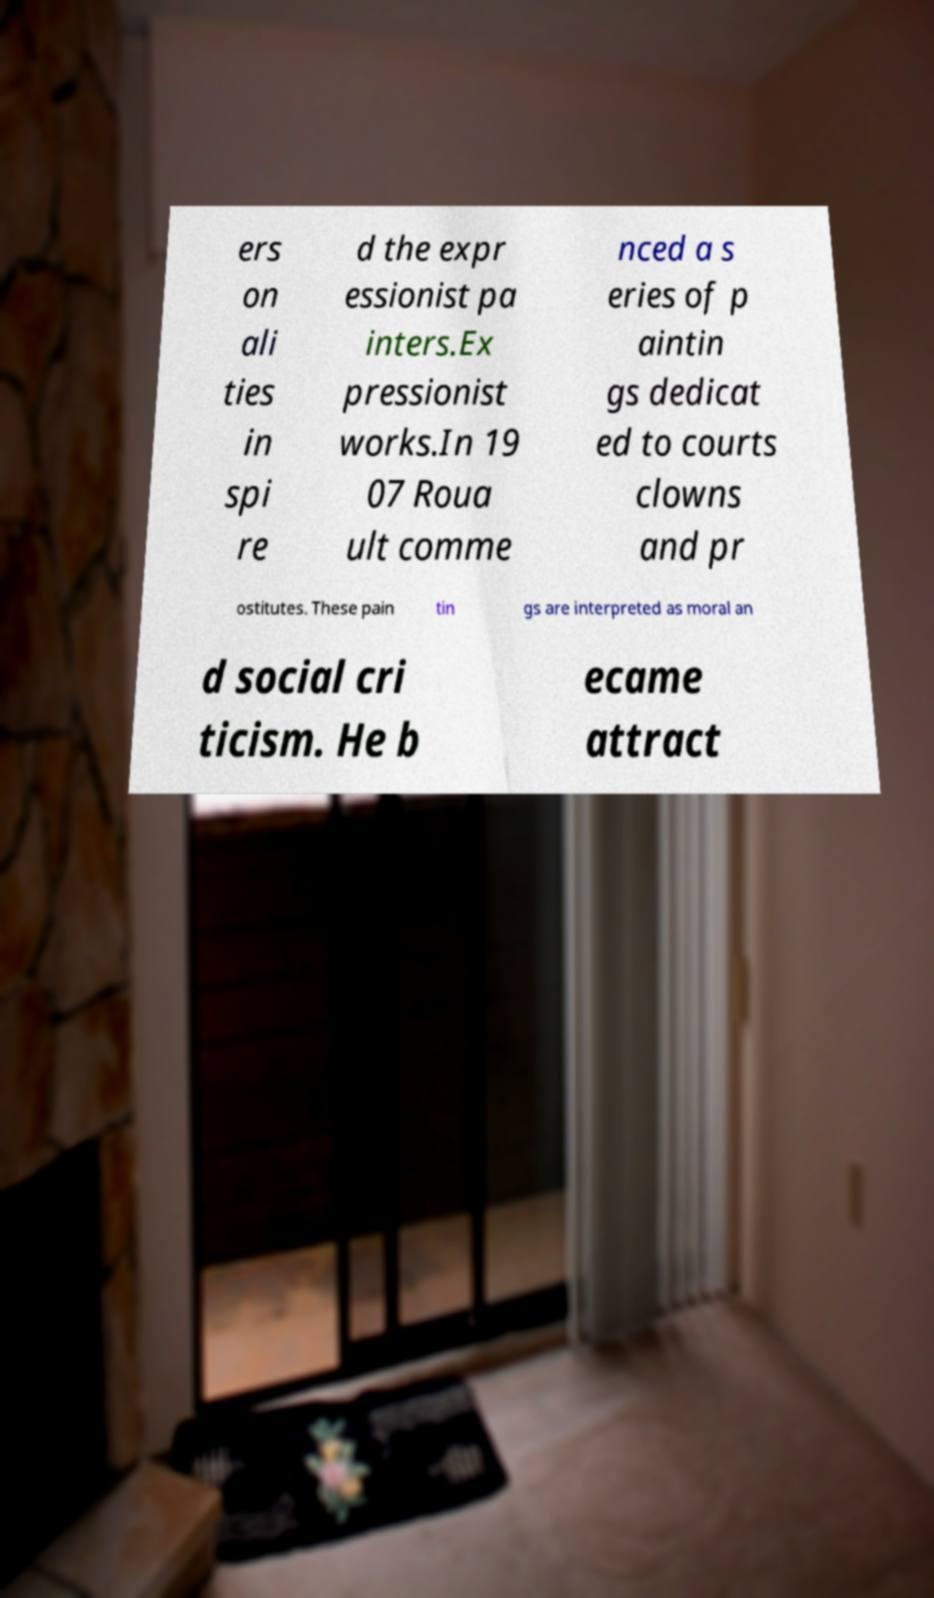Please read and relay the text visible in this image. What does it say? ers on ali ties in spi re d the expr essionist pa inters.Ex pressionist works.In 19 07 Roua ult comme nced a s eries of p aintin gs dedicat ed to courts clowns and pr ostitutes. These pain tin gs are interpreted as moral an d social cri ticism. He b ecame attract 